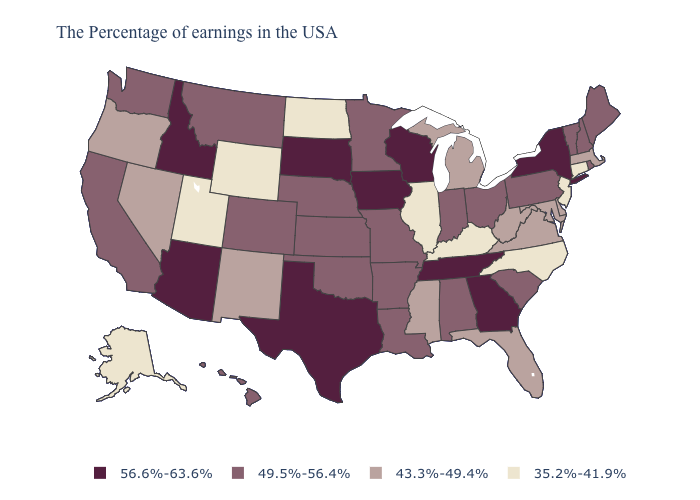Name the states that have a value in the range 49.5%-56.4%?
Quick response, please. Maine, Rhode Island, New Hampshire, Vermont, Pennsylvania, South Carolina, Ohio, Indiana, Alabama, Louisiana, Missouri, Arkansas, Minnesota, Kansas, Nebraska, Oklahoma, Colorado, Montana, California, Washington, Hawaii. Which states hav the highest value in the MidWest?
Keep it brief. Wisconsin, Iowa, South Dakota. Name the states that have a value in the range 43.3%-49.4%?
Short answer required. Massachusetts, Delaware, Maryland, Virginia, West Virginia, Florida, Michigan, Mississippi, New Mexico, Nevada, Oregon. Which states have the lowest value in the USA?
Quick response, please. Connecticut, New Jersey, North Carolina, Kentucky, Illinois, North Dakota, Wyoming, Utah, Alaska. Name the states that have a value in the range 56.6%-63.6%?
Be succinct. New York, Georgia, Tennessee, Wisconsin, Iowa, Texas, South Dakota, Arizona, Idaho. What is the value of Pennsylvania?
Write a very short answer. 49.5%-56.4%. Does Arizona have the same value as California?
Answer briefly. No. How many symbols are there in the legend?
Concise answer only. 4. What is the value of Maryland?
Quick response, please. 43.3%-49.4%. Does the first symbol in the legend represent the smallest category?
Keep it brief. No. Does New Jersey have the same value as Georgia?
Give a very brief answer. No. Among the states that border New Jersey , which have the highest value?
Answer briefly. New York. Which states have the lowest value in the USA?
Concise answer only. Connecticut, New Jersey, North Carolina, Kentucky, Illinois, North Dakota, Wyoming, Utah, Alaska. What is the lowest value in the USA?
Short answer required. 35.2%-41.9%. Name the states that have a value in the range 43.3%-49.4%?
Quick response, please. Massachusetts, Delaware, Maryland, Virginia, West Virginia, Florida, Michigan, Mississippi, New Mexico, Nevada, Oregon. 